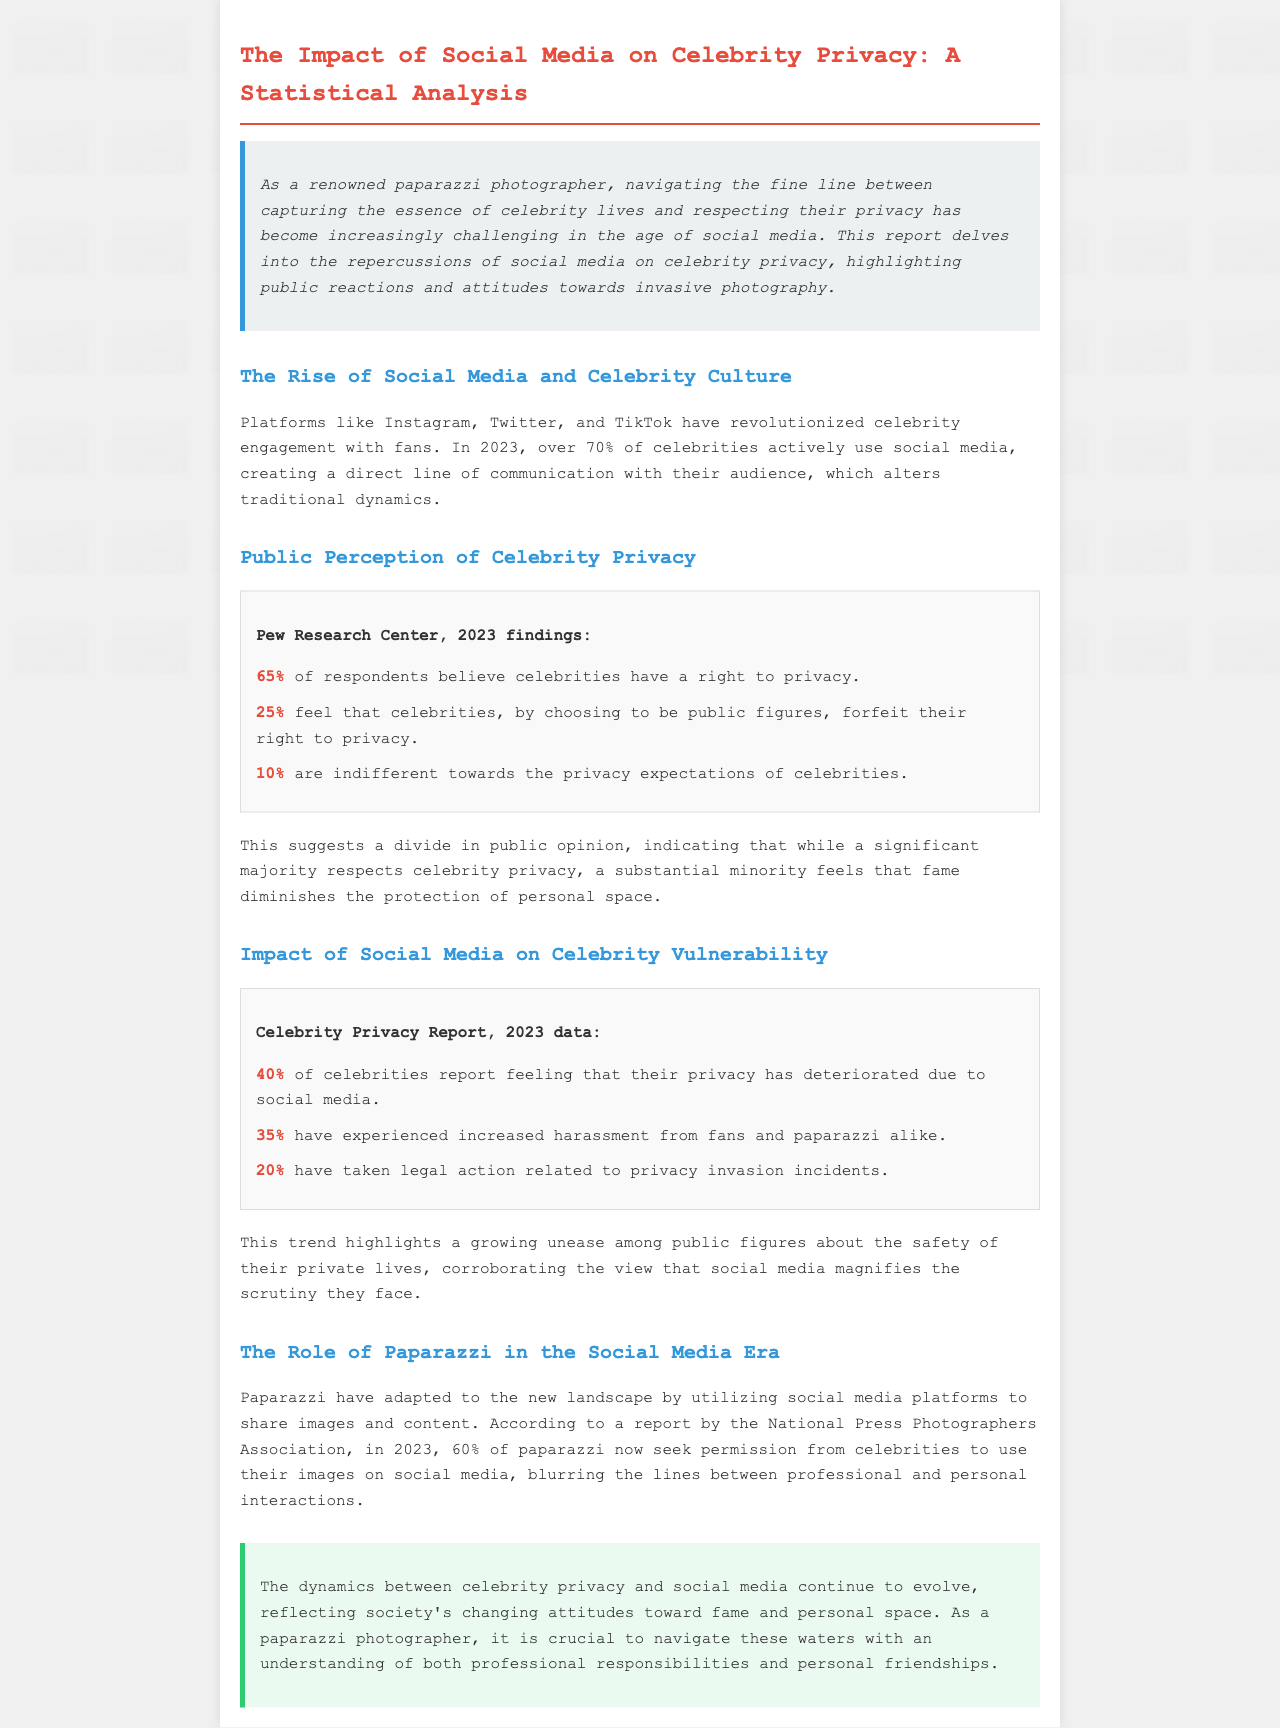what percentage of celebrities use social media? The report states that over 70% of celebrities actively use social media in 2023.
Answer: over 70% what percentage of respondents believe celebrities have a right to privacy? According to Pew Research Center, 65% of respondents believe that celebrities have a right to privacy.
Answer: 65% how many celebrities report privacy deterioration due to social media? The report indicates that 40% of celebrities report feeling that their privacy has deteriorated due to social media.
Answer: 40% what percentage of paparazzi seek permission to use images on social media? The report mentions that 60% of paparazzi seek permission from celebrities to use their images on social media.
Answer: 60% what is the percentage of respondents indifferent to celebrity privacy? The document states that 10% of respondents are indifferent towards the privacy expectations of celebrities.
Answer: 10% what percentage of celebrities have taken legal action related to privacy invasion? According to the report, 20% of celebrities have taken legal action related to privacy invasion incidents.
Answer: 20% what does the report suggest about public opinion towards celebrity privacy? It suggests a divide in public opinion, indicating that a significant majority respects celebrity privacy, while some feel that fame diminishes personal space.
Answer: significant majority respects privacy what was the key finding from the Celebrity Privacy Report in 2023? The key finding was that 40% of celebrities feel their privacy has deteriorated due to social media.
Answer: 40% what aspect of paparazzi interaction with celebrities has changed according to the document? Paparazzi have adapted by utilizing social media platforms to share images and content.
Answer: utilization of social media 